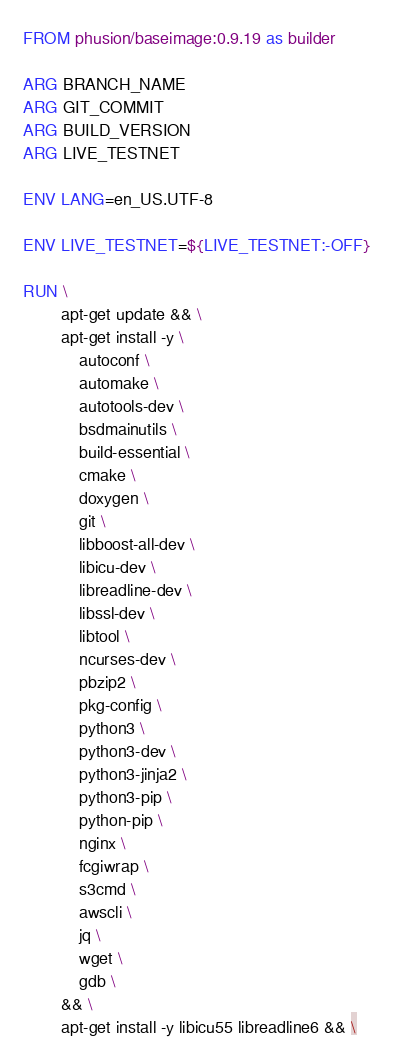Convert code to text. <code><loc_0><loc_0><loc_500><loc_500><_Dockerfile_>FROM phusion/baseimage:0.9.19 as builder

ARG BRANCH_NAME
ARG GIT_COMMIT
ARG BUILD_VERSION
ARG LIVE_TESTNET

ENV LANG=en_US.UTF-8

ENV LIVE_TESTNET=${LIVE_TESTNET:-OFF}

RUN \
        apt-get update && \
        apt-get install -y \
            autoconf \
            automake \
            autotools-dev \
            bsdmainutils \
            build-essential \
            cmake \
            doxygen \
            git \
            libboost-all-dev \
            libicu-dev \
            libreadline-dev \
            libssl-dev \
            libtool \
            ncurses-dev \
            pbzip2 \
            pkg-config \
            python3 \
            python3-dev \
            python3-jinja2 \
            python3-pip \
            python-pip \
            nginx \
            fcgiwrap \
            s3cmd \
            awscli \
            jq \
            wget \
            gdb \
        && \
        apt-get install -y libicu55 libreadline6 && \</code> 